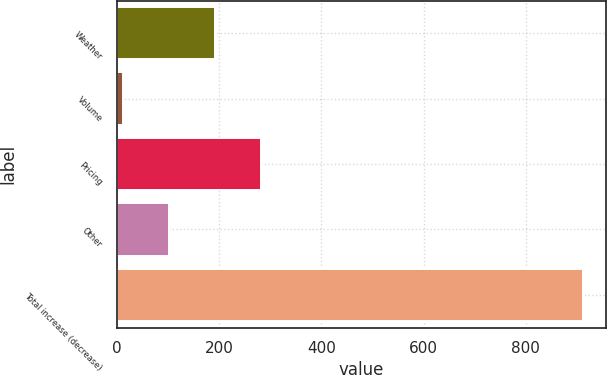<chart> <loc_0><loc_0><loc_500><loc_500><bar_chart><fcel>Weather<fcel>Volume<fcel>Pricing<fcel>Other<fcel>Total increase (decrease)<nl><fcel>191.2<fcel>11<fcel>281.3<fcel>101.1<fcel>912<nl></chart> 